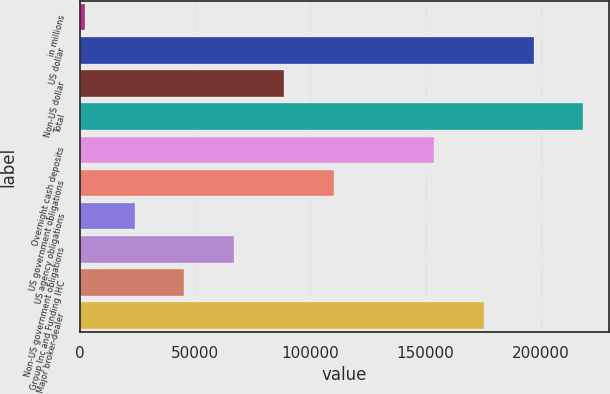Convert chart. <chart><loc_0><loc_0><loc_500><loc_500><bar_chart><fcel>in millions<fcel>US dollar<fcel>Non-US dollar<fcel>Total<fcel>Overnight cash deposits<fcel>US government obligations<fcel>US agency obligations<fcel>Non-US government obligations<fcel>Group Inc and Funding IHC<fcel>Major broker-dealer<nl><fcel>2017<fcel>196895<fcel>88629.4<fcel>218548<fcel>153589<fcel>110282<fcel>23670.1<fcel>66976.3<fcel>45323.2<fcel>175242<nl></chart> 